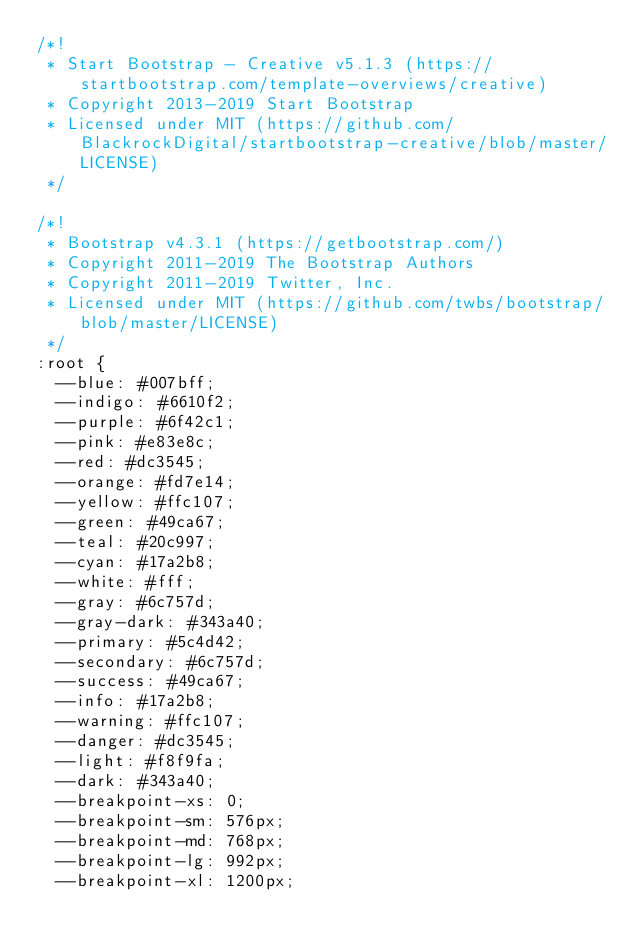<code> <loc_0><loc_0><loc_500><loc_500><_CSS_>/*!
 * Start Bootstrap - Creative v5.1.3 (https://startbootstrap.com/template-overviews/creative)
 * Copyright 2013-2019 Start Bootstrap
 * Licensed under MIT (https://github.com/BlackrockDigital/startbootstrap-creative/blob/master/LICENSE)
 */

/*!
 * Bootstrap v4.3.1 (https://getbootstrap.com/)
 * Copyright 2011-2019 The Bootstrap Authors
 * Copyright 2011-2019 Twitter, Inc.
 * Licensed under MIT (https://github.com/twbs/bootstrap/blob/master/LICENSE)
 */
:root {
  --blue: #007bff;
  --indigo: #6610f2;
  --purple: #6f42c1;
  --pink: #e83e8c;
  --red: #dc3545;
  --orange: #fd7e14;
  --yellow: #ffc107;
  --green: #49ca67;
  --teal: #20c997;
  --cyan: #17a2b8;
  --white: #fff;
  --gray: #6c757d;
  --gray-dark: #343a40;
  --primary: #5c4d42;
  --secondary: #6c757d;
  --success: #49ca67;
  --info: #17a2b8;
  --warning: #ffc107;
  --danger: #dc3545;
  --light: #f8f9fa;
  --dark: #343a40;
  --breakpoint-xs: 0;
  --breakpoint-sm: 576px;
  --breakpoint-md: 768px;
  --breakpoint-lg: 992px;
  --breakpoint-xl: 1200px;</code> 